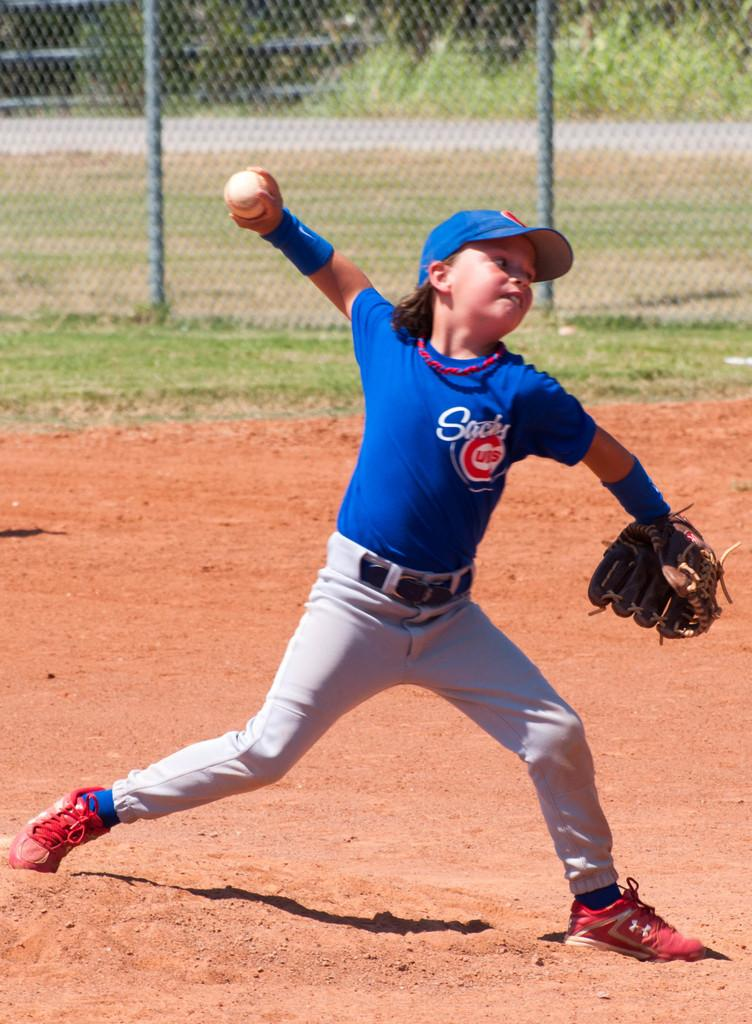<image>
Share a concise interpretation of the image provided. Little kid on a baseball field with a sachs jersey on 